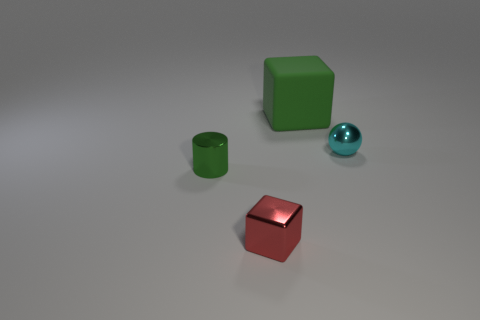Add 2 matte cubes. How many objects exist? 6 Subtract all spheres. How many objects are left? 3 Add 4 small cyan objects. How many small cyan objects are left? 5 Add 2 big green matte objects. How many big green matte objects exist? 3 Subtract 0 cyan cylinders. How many objects are left? 4 Subtract all small objects. Subtract all small red spheres. How many objects are left? 1 